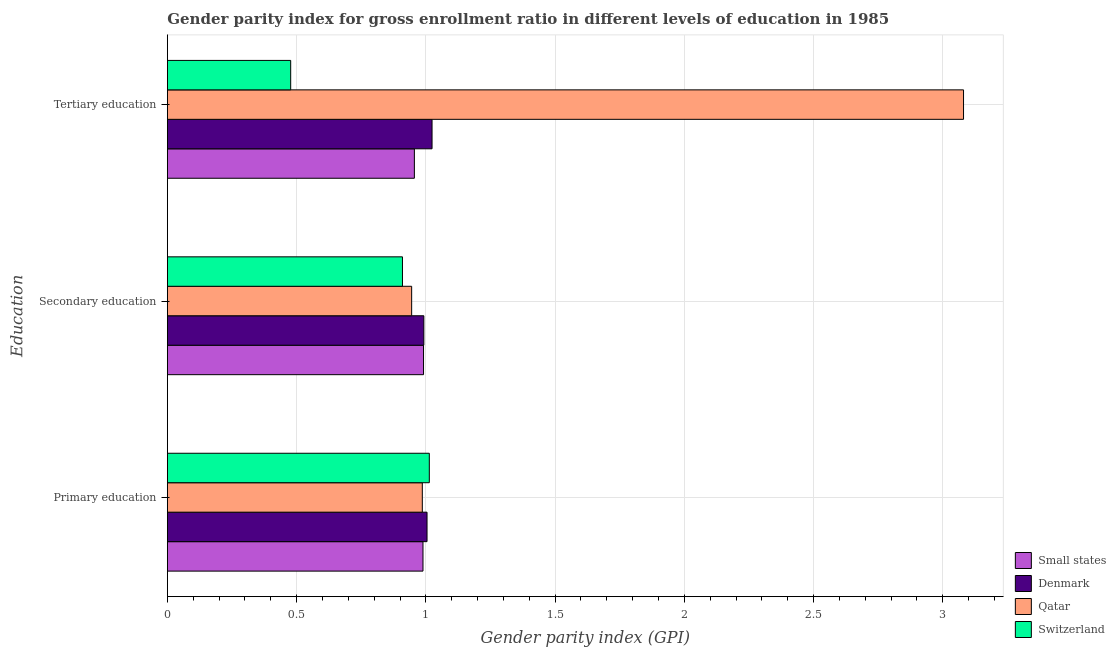How many different coloured bars are there?
Make the answer very short. 4. Are the number of bars per tick equal to the number of legend labels?
Provide a succinct answer. Yes. Are the number of bars on each tick of the Y-axis equal?
Give a very brief answer. Yes. How many bars are there on the 1st tick from the top?
Keep it short and to the point. 4. What is the label of the 2nd group of bars from the top?
Give a very brief answer. Secondary education. What is the gender parity index in secondary education in Qatar?
Ensure brevity in your answer.  0.95. Across all countries, what is the maximum gender parity index in secondary education?
Give a very brief answer. 0.99. Across all countries, what is the minimum gender parity index in primary education?
Keep it short and to the point. 0.99. In which country was the gender parity index in primary education maximum?
Offer a very short reply. Switzerland. In which country was the gender parity index in tertiary education minimum?
Your answer should be compact. Switzerland. What is the total gender parity index in primary education in the graph?
Offer a terse response. 3.99. What is the difference between the gender parity index in primary education in Switzerland and that in Denmark?
Your answer should be compact. 0.01. What is the difference between the gender parity index in primary education in Switzerland and the gender parity index in secondary education in Small states?
Make the answer very short. 0.02. What is the average gender parity index in secondary education per country?
Make the answer very short. 0.96. What is the difference between the gender parity index in secondary education and gender parity index in tertiary education in Switzerland?
Your answer should be very brief. 0.43. In how many countries, is the gender parity index in secondary education greater than 1 ?
Your response must be concise. 0. What is the ratio of the gender parity index in secondary education in Switzerland to that in Qatar?
Offer a terse response. 0.96. What is the difference between the highest and the second highest gender parity index in secondary education?
Offer a very short reply. 0. What is the difference between the highest and the lowest gender parity index in tertiary education?
Provide a short and direct response. 2.6. What does the 2nd bar from the bottom in Primary education represents?
Provide a short and direct response. Denmark. Is it the case that in every country, the sum of the gender parity index in primary education and gender parity index in secondary education is greater than the gender parity index in tertiary education?
Ensure brevity in your answer.  No. How many countries are there in the graph?
Give a very brief answer. 4. What is the difference between two consecutive major ticks on the X-axis?
Your answer should be compact. 0.5. Does the graph contain any zero values?
Your response must be concise. No. Where does the legend appear in the graph?
Give a very brief answer. Bottom right. What is the title of the graph?
Offer a terse response. Gender parity index for gross enrollment ratio in different levels of education in 1985. Does "Philippines" appear as one of the legend labels in the graph?
Provide a succinct answer. No. What is the label or title of the X-axis?
Give a very brief answer. Gender parity index (GPI). What is the label or title of the Y-axis?
Keep it short and to the point. Education. What is the Gender parity index (GPI) in Small states in Primary education?
Make the answer very short. 0.99. What is the Gender parity index (GPI) of Denmark in Primary education?
Your answer should be very brief. 1. What is the Gender parity index (GPI) in Qatar in Primary education?
Give a very brief answer. 0.99. What is the Gender parity index (GPI) in Switzerland in Primary education?
Your answer should be compact. 1.01. What is the Gender parity index (GPI) in Small states in Secondary education?
Your answer should be very brief. 0.99. What is the Gender parity index (GPI) in Denmark in Secondary education?
Keep it short and to the point. 0.99. What is the Gender parity index (GPI) in Qatar in Secondary education?
Ensure brevity in your answer.  0.95. What is the Gender parity index (GPI) of Switzerland in Secondary education?
Give a very brief answer. 0.91. What is the Gender parity index (GPI) of Small states in Tertiary education?
Ensure brevity in your answer.  0.96. What is the Gender parity index (GPI) of Qatar in Tertiary education?
Provide a short and direct response. 3.08. What is the Gender parity index (GPI) of Switzerland in Tertiary education?
Make the answer very short. 0.48. Across all Education, what is the maximum Gender parity index (GPI) in Small states?
Your answer should be compact. 0.99. Across all Education, what is the maximum Gender parity index (GPI) of Denmark?
Provide a short and direct response. 1.02. Across all Education, what is the maximum Gender parity index (GPI) of Qatar?
Ensure brevity in your answer.  3.08. Across all Education, what is the maximum Gender parity index (GPI) of Switzerland?
Your answer should be compact. 1.01. Across all Education, what is the minimum Gender parity index (GPI) of Small states?
Provide a succinct answer. 0.96. Across all Education, what is the minimum Gender parity index (GPI) of Denmark?
Ensure brevity in your answer.  0.99. Across all Education, what is the minimum Gender parity index (GPI) in Qatar?
Offer a terse response. 0.95. Across all Education, what is the minimum Gender parity index (GPI) of Switzerland?
Make the answer very short. 0.48. What is the total Gender parity index (GPI) of Small states in the graph?
Keep it short and to the point. 2.94. What is the total Gender parity index (GPI) in Denmark in the graph?
Provide a succinct answer. 3.02. What is the total Gender parity index (GPI) of Qatar in the graph?
Give a very brief answer. 5.01. What is the difference between the Gender parity index (GPI) of Small states in Primary education and that in Secondary education?
Your answer should be compact. -0. What is the difference between the Gender parity index (GPI) in Denmark in Primary education and that in Secondary education?
Provide a succinct answer. 0.01. What is the difference between the Gender parity index (GPI) in Qatar in Primary education and that in Secondary education?
Keep it short and to the point. 0.04. What is the difference between the Gender parity index (GPI) of Switzerland in Primary education and that in Secondary education?
Your answer should be very brief. 0.1. What is the difference between the Gender parity index (GPI) of Denmark in Primary education and that in Tertiary education?
Provide a succinct answer. -0.02. What is the difference between the Gender parity index (GPI) of Qatar in Primary education and that in Tertiary education?
Give a very brief answer. -2.09. What is the difference between the Gender parity index (GPI) in Switzerland in Primary education and that in Tertiary education?
Offer a terse response. 0.54. What is the difference between the Gender parity index (GPI) in Small states in Secondary education and that in Tertiary education?
Provide a short and direct response. 0.04. What is the difference between the Gender parity index (GPI) in Denmark in Secondary education and that in Tertiary education?
Provide a succinct answer. -0.03. What is the difference between the Gender parity index (GPI) in Qatar in Secondary education and that in Tertiary education?
Give a very brief answer. -2.14. What is the difference between the Gender parity index (GPI) of Switzerland in Secondary education and that in Tertiary education?
Offer a very short reply. 0.43. What is the difference between the Gender parity index (GPI) of Small states in Primary education and the Gender parity index (GPI) of Denmark in Secondary education?
Ensure brevity in your answer.  -0. What is the difference between the Gender parity index (GPI) of Small states in Primary education and the Gender parity index (GPI) of Qatar in Secondary education?
Offer a very short reply. 0.04. What is the difference between the Gender parity index (GPI) of Small states in Primary education and the Gender parity index (GPI) of Switzerland in Secondary education?
Give a very brief answer. 0.08. What is the difference between the Gender parity index (GPI) in Denmark in Primary education and the Gender parity index (GPI) in Qatar in Secondary education?
Your response must be concise. 0.06. What is the difference between the Gender parity index (GPI) in Denmark in Primary education and the Gender parity index (GPI) in Switzerland in Secondary education?
Provide a succinct answer. 0.1. What is the difference between the Gender parity index (GPI) in Qatar in Primary education and the Gender parity index (GPI) in Switzerland in Secondary education?
Keep it short and to the point. 0.08. What is the difference between the Gender parity index (GPI) of Small states in Primary education and the Gender parity index (GPI) of Denmark in Tertiary education?
Provide a short and direct response. -0.04. What is the difference between the Gender parity index (GPI) in Small states in Primary education and the Gender parity index (GPI) in Qatar in Tertiary education?
Offer a very short reply. -2.09. What is the difference between the Gender parity index (GPI) of Small states in Primary education and the Gender parity index (GPI) of Switzerland in Tertiary education?
Make the answer very short. 0.51. What is the difference between the Gender parity index (GPI) of Denmark in Primary education and the Gender parity index (GPI) of Qatar in Tertiary education?
Give a very brief answer. -2.08. What is the difference between the Gender parity index (GPI) of Denmark in Primary education and the Gender parity index (GPI) of Switzerland in Tertiary education?
Your response must be concise. 0.53. What is the difference between the Gender parity index (GPI) of Qatar in Primary education and the Gender parity index (GPI) of Switzerland in Tertiary education?
Make the answer very short. 0.51. What is the difference between the Gender parity index (GPI) in Small states in Secondary education and the Gender parity index (GPI) in Denmark in Tertiary education?
Provide a succinct answer. -0.03. What is the difference between the Gender parity index (GPI) of Small states in Secondary education and the Gender parity index (GPI) of Qatar in Tertiary education?
Keep it short and to the point. -2.09. What is the difference between the Gender parity index (GPI) of Small states in Secondary education and the Gender parity index (GPI) of Switzerland in Tertiary education?
Ensure brevity in your answer.  0.51. What is the difference between the Gender parity index (GPI) of Denmark in Secondary education and the Gender parity index (GPI) of Qatar in Tertiary education?
Keep it short and to the point. -2.09. What is the difference between the Gender parity index (GPI) in Denmark in Secondary education and the Gender parity index (GPI) in Switzerland in Tertiary education?
Give a very brief answer. 0.52. What is the difference between the Gender parity index (GPI) in Qatar in Secondary education and the Gender parity index (GPI) in Switzerland in Tertiary education?
Your response must be concise. 0.47. What is the average Gender parity index (GPI) of Small states per Education?
Make the answer very short. 0.98. What is the average Gender parity index (GPI) of Qatar per Education?
Provide a short and direct response. 1.67. What is the average Gender parity index (GPI) in Switzerland per Education?
Keep it short and to the point. 0.8. What is the difference between the Gender parity index (GPI) in Small states and Gender parity index (GPI) in Denmark in Primary education?
Offer a terse response. -0.02. What is the difference between the Gender parity index (GPI) of Small states and Gender parity index (GPI) of Qatar in Primary education?
Your answer should be very brief. 0. What is the difference between the Gender parity index (GPI) in Small states and Gender parity index (GPI) in Switzerland in Primary education?
Provide a succinct answer. -0.02. What is the difference between the Gender parity index (GPI) in Denmark and Gender parity index (GPI) in Qatar in Primary education?
Offer a terse response. 0.02. What is the difference between the Gender parity index (GPI) of Denmark and Gender parity index (GPI) of Switzerland in Primary education?
Your answer should be very brief. -0.01. What is the difference between the Gender parity index (GPI) of Qatar and Gender parity index (GPI) of Switzerland in Primary education?
Give a very brief answer. -0.03. What is the difference between the Gender parity index (GPI) in Small states and Gender parity index (GPI) in Denmark in Secondary education?
Your answer should be very brief. -0. What is the difference between the Gender parity index (GPI) of Small states and Gender parity index (GPI) of Qatar in Secondary education?
Keep it short and to the point. 0.05. What is the difference between the Gender parity index (GPI) of Small states and Gender parity index (GPI) of Switzerland in Secondary education?
Make the answer very short. 0.08. What is the difference between the Gender parity index (GPI) in Denmark and Gender parity index (GPI) in Qatar in Secondary education?
Your response must be concise. 0.05. What is the difference between the Gender parity index (GPI) in Denmark and Gender parity index (GPI) in Switzerland in Secondary education?
Offer a very short reply. 0.08. What is the difference between the Gender parity index (GPI) of Qatar and Gender parity index (GPI) of Switzerland in Secondary education?
Provide a short and direct response. 0.04. What is the difference between the Gender parity index (GPI) of Small states and Gender parity index (GPI) of Denmark in Tertiary education?
Provide a succinct answer. -0.07. What is the difference between the Gender parity index (GPI) in Small states and Gender parity index (GPI) in Qatar in Tertiary education?
Provide a short and direct response. -2.12. What is the difference between the Gender parity index (GPI) in Small states and Gender parity index (GPI) in Switzerland in Tertiary education?
Give a very brief answer. 0.48. What is the difference between the Gender parity index (GPI) of Denmark and Gender parity index (GPI) of Qatar in Tertiary education?
Your answer should be compact. -2.06. What is the difference between the Gender parity index (GPI) of Denmark and Gender parity index (GPI) of Switzerland in Tertiary education?
Provide a succinct answer. 0.55. What is the difference between the Gender parity index (GPI) of Qatar and Gender parity index (GPI) of Switzerland in Tertiary education?
Make the answer very short. 2.6. What is the ratio of the Gender parity index (GPI) in Denmark in Primary education to that in Secondary education?
Ensure brevity in your answer.  1.01. What is the ratio of the Gender parity index (GPI) of Qatar in Primary education to that in Secondary education?
Your answer should be very brief. 1.04. What is the ratio of the Gender parity index (GPI) in Switzerland in Primary education to that in Secondary education?
Provide a short and direct response. 1.11. What is the ratio of the Gender parity index (GPI) in Small states in Primary education to that in Tertiary education?
Offer a terse response. 1.03. What is the ratio of the Gender parity index (GPI) in Denmark in Primary education to that in Tertiary education?
Your response must be concise. 0.98. What is the ratio of the Gender parity index (GPI) of Qatar in Primary education to that in Tertiary education?
Your response must be concise. 0.32. What is the ratio of the Gender parity index (GPI) in Switzerland in Primary education to that in Tertiary education?
Keep it short and to the point. 2.12. What is the ratio of the Gender parity index (GPI) of Small states in Secondary education to that in Tertiary education?
Give a very brief answer. 1.04. What is the ratio of the Gender parity index (GPI) in Qatar in Secondary education to that in Tertiary education?
Offer a very short reply. 0.31. What is the ratio of the Gender parity index (GPI) of Switzerland in Secondary education to that in Tertiary education?
Give a very brief answer. 1.91. What is the difference between the highest and the second highest Gender parity index (GPI) in Small states?
Provide a succinct answer. 0. What is the difference between the highest and the second highest Gender parity index (GPI) in Denmark?
Your answer should be compact. 0.02. What is the difference between the highest and the second highest Gender parity index (GPI) of Qatar?
Your response must be concise. 2.09. What is the difference between the highest and the second highest Gender parity index (GPI) of Switzerland?
Your response must be concise. 0.1. What is the difference between the highest and the lowest Gender parity index (GPI) of Small states?
Keep it short and to the point. 0.04. What is the difference between the highest and the lowest Gender parity index (GPI) in Denmark?
Keep it short and to the point. 0.03. What is the difference between the highest and the lowest Gender parity index (GPI) of Qatar?
Ensure brevity in your answer.  2.14. What is the difference between the highest and the lowest Gender parity index (GPI) of Switzerland?
Your answer should be compact. 0.54. 